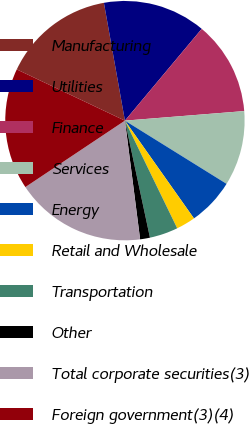<chart> <loc_0><loc_0><loc_500><loc_500><pie_chart><fcel>Manufacturing<fcel>Utilities<fcel>Finance<fcel>Services<fcel>Energy<fcel>Retail and Wholesale<fcel>Transportation<fcel>Other<fcel>Total corporate securities(3)<fcel>Foreign government(3)(4)<nl><fcel>15.15%<fcel>13.9%<fcel>12.64%<fcel>10.13%<fcel>6.36%<fcel>2.59%<fcel>3.84%<fcel>1.33%<fcel>17.66%<fcel>16.41%<nl></chart> 